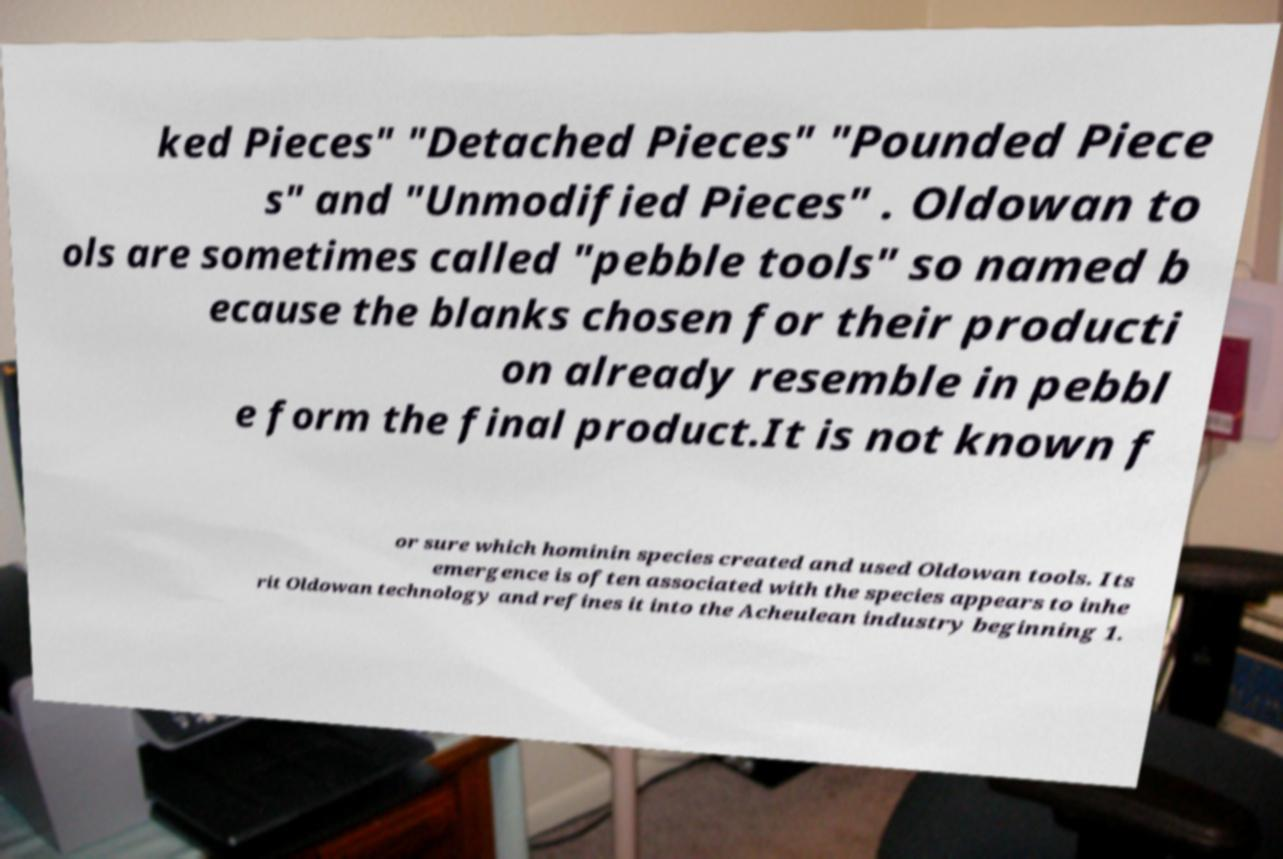There's text embedded in this image that I need extracted. Can you transcribe it verbatim? ked Pieces" "Detached Pieces" "Pounded Piece s" and "Unmodified Pieces" . Oldowan to ols are sometimes called "pebble tools" so named b ecause the blanks chosen for their producti on already resemble in pebbl e form the final product.It is not known f or sure which hominin species created and used Oldowan tools. Its emergence is often associated with the species appears to inhe rit Oldowan technology and refines it into the Acheulean industry beginning 1. 